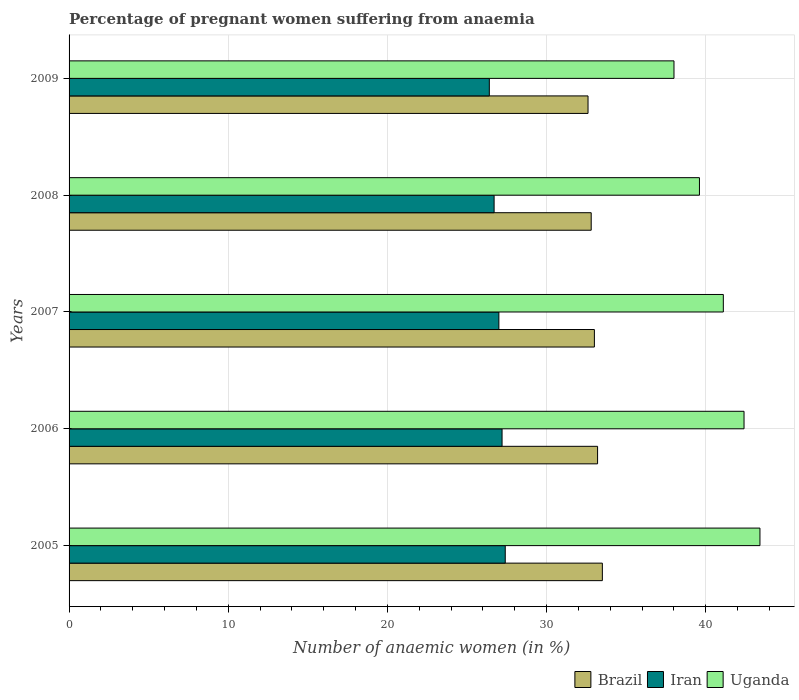How many groups of bars are there?
Offer a terse response. 5. Are the number of bars on each tick of the Y-axis equal?
Your response must be concise. Yes. How many bars are there on the 5th tick from the top?
Your answer should be compact. 3. How many bars are there on the 2nd tick from the bottom?
Provide a short and direct response. 3. What is the number of anaemic women in Brazil in 2006?
Provide a succinct answer. 33.2. Across all years, what is the maximum number of anaemic women in Iran?
Your answer should be very brief. 27.4. In which year was the number of anaemic women in Uganda maximum?
Make the answer very short. 2005. What is the total number of anaemic women in Brazil in the graph?
Your answer should be compact. 165.1. What is the difference between the number of anaemic women in Brazil in 2006 and that in 2007?
Your response must be concise. 0.2. What is the difference between the number of anaemic women in Brazil in 2005 and the number of anaemic women in Uganda in 2008?
Keep it short and to the point. -6.1. What is the average number of anaemic women in Iran per year?
Provide a succinct answer. 26.94. In the year 2007, what is the difference between the number of anaemic women in Brazil and number of anaemic women in Uganda?
Make the answer very short. -8.1. In how many years, is the number of anaemic women in Uganda greater than 34 %?
Offer a very short reply. 5. What is the ratio of the number of anaemic women in Uganda in 2005 to that in 2006?
Your answer should be very brief. 1.02. Is the number of anaemic women in Iran in 2006 less than that in 2007?
Your answer should be compact. No. Is the difference between the number of anaemic women in Brazil in 2007 and 2008 greater than the difference between the number of anaemic women in Uganda in 2007 and 2008?
Provide a succinct answer. No. What is the difference between the highest and the second highest number of anaemic women in Iran?
Offer a very short reply. 0.2. What is the difference between the highest and the lowest number of anaemic women in Uganda?
Make the answer very short. 5.4. In how many years, is the number of anaemic women in Brazil greater than the average number of anaemic women in Brazil taken over all years?
Provide a succinct answer. 2. Is the sum of the number of anaemic women in Brazil in 2005 and 2009 greater than the maximum number of anaemic women in Iran across all years?
Your answer should be very brief. Yes. What does the 1st bar from the top in 2006 represents?
Offer a terse response. Uganda. What does the 2nd bar from the bottom in 2007 represents?
Your response must be concise. Iran. Is it the case that in every year, the sum of the number of anaemic women in Iran and number of anaemic women in Uganda is greater than the number of anaemic women in Brazil?
Ensure brevity in your answer.  Yes. How many bars are there?
Ensure brevity in your answer.  15. Does the graph contain grids?
Keep it short and to the point. Yes. How many legend labels are there?
Ensure brevity in your answer.  3. How are the legend labels stacked?
Keep it short and to the point. Horizontal. What is the title of the graph?
Offer a very short reply. Percentage of pregnant women suffering from anaemia. Does "France" appear as one of the legend labels in the graph?
Your answer should be very brief. No. What is the label or title of the X-axis?
Provide a short and direct response. Number of anaemic women (in %). What is the label or title of the Y-axis?
Your response must be concise. Years. What is the Number of anaemic women (in %) in Brazil in 2005?
Give a very brief answer. 33.5. What is the Number of anaemic women (in %) in Iran in 2005?
Provide a short and direct response. 27.4. What is the Number of anaemic women (in %) in Uganda in 2005?
Your response must be concise. 43.4. What is the Number of anaemic women (in %) of Brazil in 2006?
Your answer should be compact. 33.2. What is the Number of anaemic women (in %) of Iran in 2006?
Your response must be concise. 27.2. What is the Number of anaemic women (in %) in Uganda in 2006?
Provide a short and direct response. 42.4. What is the Number of anaemic women (in %) in Iran in 2007?
Ensure brevity in your answer.  27. What is the Number of anaemic women (in %) in Uganda in 2007?
Keep it short and to the point. 41.1. What is the Number of anaemic women (in %) in Brazil in 2008?
Offer a very short reply. 32.8. What is the Number of anaemic women (in %) in Iran in 2008?
Your answer should be compact. 26.7. What is the Number of anaemic women (in %) in Uganda in 2008?
Provide a succinct answer. 39.6. What is the Number of anaemic women (in %) in Brazil in 2009?
Make the answer very short. 32.6. What is the Number of anaemic women (in %) of Iran in 2009?
Your response must be concise. 26.4. Across all years, what is the maximum Number of anaemic women (in %) in Brazil?
Keep it short and to the point. 33.5. Across all years, what is the maximum Number of anaemic women (in %) in Iran?
Ensure brevity in your answer.  27.4. Across all years, what is the maximum Number of anaemic women (in %) in Uganda?
Give a very brief answer. 43.4. Across all years, what is the minimum Number of anaemic women (in %) of Brazil?
Make the answer very short. 32.6. Across all years, what is the minimum Number of anaemic women (in %) in Iran?
Your answer should be very brief. 26.4. Across all years, what is the minimum Number of anaemic women (in %) in Uganda?
Provide a short and direct response. 38. What is the total Number of anaemic women (in %) in Brazil in the graph?
Your answer should be compact. 165.1. What is the total Number of anaemic women (in %) in Iran in the graph?
Offer a terse response. 134.7. What is the total Number of anaemic women (in %) of Uganda in the graph?
Offer a very short reply. 204.5. What is the difference between the Number of anaemic women (in %) in Brazil in 2005 and that in 2006?
Make the answer very short. 0.3. What is the difference between the Number of anaemic women (in %) of Iran in 2005 and that in 2006?
Offer a terse response. 0.2. What is the difference between the Number of anaemic women (in %) of Uganda in 2005 and that in 2006?
Make the answer very short. 1. What is the difference between the Number of anaemic women (in %) in Brazil in 2005 and that in 2007?
Provide a short and direct response. 0.5. What is the difference between the Number of anaemic women (in %) of Uganda in 2005 and that in 2007?
Your response must be concise. 2.3. What is the difference between the Number of anaemic women (in %) in Iran in 2005 and that in 2009?
Give a very brief answer. 1. What is the difference between the Number of anaemic women (in %) in Uganda in 2005 and that in 2009?
Offer a terse response. 5.4. What is the difference between the Number of anaemic women (in %) in Iran in 2006 and that in 2007?
Give a very brief answer. 0.2. What is the difference between the Number of anaemic women (in %) in Brazil in 2006 and that in 2008?
Your answer should be very brief. 0.4. What is the difference between the Number of anaemic women (in %) in Iran in 2006 and that in 2008?
Offer a very short reply. 0.5. What is the difference between the Number of anaemic women (in %) in Iran in 2007 and that in 2008?
Ensure brevity in your answer.  0.3. What is the difference between the Number of anaemic women (in %) in Uganda in 2007 and that in 2008?
Provide a succinct answer. 1.5. What is the difference between the Number of anaemic women (in %) of Brazil in 2007 and that in 2009?
Provide a short and direct response. 0.4. What is the difference between the Number of anaemic women (in %) in Uganda in 2007 and that in 2009?
Provide a short and direct response. 3.1. What is the difference between the Number of anaemic women (in %) in Iran in 2008 and that in 2009?
Make the answer very short. 0.3. What is the difference between the Number of anaemic women (in %) in Brazil in 2005 and the Number of anaemic women (in %) in Uganda in 2006?
Keep it short and to the point. -8.9. What is the difference between the Number of anaemic women (in %) of Brazil in 2005 and the Number of anaemic women (in %) of Iran in 2007?
Your response must be concise. 6.5. What is the difference between the Number of anaemic women (in %) in Brazil in 2005 and the Number of anaemic women (in %) in Uganda in 2007?
Provide a short and direct response. -7.6. What is the difference between the Number of anaemic women (in %) in Iran in 2005 and the Number of anaemic women (in %) in Uganda in 2007?
Give a very brief answer. -13.7. What is the difference between the Number of anaemic women (in %) in Brazil in 2005 and the Number of anaemic women (in %) in Uganda in 2008?
Provide a short and direct response. -6.1. What is the difference between the Number of anaemic women (in %) of Brazil in 2005 and the Number of anaemic women (in %) of Uganda in 2009?
Make the answer very short. -4.5. What is the difference between the Number of anaemic women (in %) in Iran in 2005 and the Number of anaemic women (in %) in Uganda in 2009?
Give a very brief answer. -10.6. What is the difference between the Number of anaemic women (in %) of Brazil in 2006 and the Number of anaemic women (in %) of Iran in 2007?
Your answer should be very brief. 6.2. What is the difference between the Number of anaemic women (in %) of Brazil in 2006 and the Number of anaemic women (in %) of Uganda in 2007?
Give a very brief answer. -7.9. What is the difference between the Number of anaemic women (in %) of Iran in 2006 and the Number of anaemic women (in %) of Uganda in 2008?
Provide a short and direct response. -12.4. What is the difference between the Number of anaemic women (in %) of Brazil in 2006 and the Number of anaemic women (in %) of Uganda in 2009?
Your answer should be very brief. -4.8. What is the difference between the Number of anaemic women (in %) in Iran in 2006 and the Number of anaemic women (in %) in Uganda in 2009?
Make the answer very short. -10.8. What is the difference between the Number of anaemic women (in %) of Brazil in 2007 and the Number of anaemic women (in %) of Uganda in 2008?
Keep it short and to the point. -6.6. What is the difference between the Number of anaemic women (in %) of Iran in 2007 and the Number of anaemic women (in %) of Uganda in 2008?
Give a very brief answer. -12.6. What is the difference between the Number of anaemic women (in %) in Brazil in 2007 and the Number of anaemic women (in %) in Uganda in 2009?
Your answer should be very brief. -5. What is the difference between the Number of anaemic women (in %) of Iran in 2007 and the Number of anaemic women (in %) of Uganda in 2009?
Offer a terse response. -11. What is the difference between the Number of anaemic women (in %) in Brazil in 2008 and the Number of anaemic women (in %) in Iran in 2009?
Provide a succinct answer. 6.4. What is the average Number of anaemic women (in %) of Brazil per year?
Your response must be concise. 33.02. What is the average Number of anaemic women (in %) in Iran per year?
Your answer should be compact. 26.94. What is the average Number of anaemic women (in %) of Uganda per year?
Keep it short and to the point. 40.9. In the year 2005, what is the difference between the Number of anaemic women (in %) in Brazil and Number of anaemic women (in %) in Iran?
Make the answer very short. 6.1. In the year 2006, what is the difference between the Number of anaemic women (in %) of Brazil and Number of anaemic women (in %) of Uganda?
Ensure brevity in your answer.  -9.2. In the year 2006, what is the difference between the Number of anaemic women (in %) of Iran and Number of anaemic women (in %) of Uganda?
Make the answer very short. -15.2. In the year 2007, what is the difference between the Number of anaemic women (in %) in Brazil and Number of anaemic women (in %) in Uganda?
Keep it short and to the point. -8.1. In the year 2007, what is the difference between the Number of anaemic women (in %) in Iran and Number of anaemic women (in %) in Uganda?
Give a very brief answer. -14.1. In the year 2008, what is the difference between the Number of anaemic women (in %) in Iran and Number of anaemic women (in %) in Uganda?
Ensure brevity in your answer.  -12.9. In the year 2009, what is the difference between the Number of anaemic women (in %) in Brazil and Number of anaemic women (in %) in Uganda?
Provide a succinct answer. -5.4. What is the ratio of the Number of anaemic women (in %) in Iran in 2005 to that in 2006?
Make the answer very short. 1.01. What is the ratio of the Number of anaemic women (in %) in Uganda in 2005 to that in 2006?
Offer a terse response. 1.02. What is the ratio of the Number of anaemic women (in %) in Brazil in 2005 to that in 2007?
Your response must be concise. 1.02. What is the ratio of the Number of anaemic women (in %) in Iran in 2005 to that in 2007?
Your answer should be compact. 1.01. What is the ratio of the Number of anaemic women (in %) of Uganda in 2005 to that in 2007?
Your answer should be very brief. 1.06. What is the ratio of the Number of anaemic women (in %) in Brazil in 2005 to that in 2008?
Provide a short and direct response. 1.02. What is the ratio of the Number of anaemic women (in %) of Iran in 2005 to that in 2008?
Make the answer very short. 1.03. What is the ratio of the Number of anaemic women (in %) of Uganda in 2005 to that in 2008?
Your answer should be very brief. 1.1. What is the ratio of the Number of anaemic women (in %) in Brazil in 2005 to that in 2009?
Provide a short and direct response. 1.03. What is the ratio of the Number of anaemic women (in %) of Iran in 2005 to that in 2009?
Ensure brevity in your answer.  1.04. What is the ratio of the Number of anaemic women (in %) in Uganda in 2005 to that in 2009?
Ensure brevity in your answer.  1.14. What is the ratio of the Number of anaemic women (in %) of Iran in 2006 to that in 2007?
Offer a terse response. 1.01. What is the ratio of the Number of anaemic women (in %) in Uganda in 2006 to that in 2007?
Make the answer very short. 1.03. What is the ratio of the Number of anaemic women (in %) in Brazil in 2006 to that in 2008?
Provide a short and direct response. 1.01. What is the ratio of the Number of anaemic women (in %) in Iran in 2006 to that in 2008?
Ensure brevity in your answer.  1.02. What is the ratio of the Number of anaemic women (in %) in Uganda in 2006 to that in 2008?
Offer a terse response. 1.07. What is the ratio of the Number of anaemic women (in %) of Brazil in 2006 to that in 2009?
Give a very brief answer. 1.02. What is the ratio of the Number of anaemic women (in %) of Iran in 2006 to that in 2009?
Ensure brevity in your answer.  1.03. What is the ratio of the Number of anaemic women (in %) of Uganda in 2006 to that in 2009?
Keep it short and to the point. 1.12. What is the ratio of the Number of anaemic women (in %) of Brazil in 2007 to that in 2008?
Your answer should be very brief. 1.01. What is the ratio of the Number of anaemic women (in %) of Iran in 2007 to that in 2008?
Keep it short and to the point. 1.01. What is the ratio of the Number of anaemic women (in %) in Uganda in 2007 to that in 2008?
Offer a terse response. 1.04. What is the ratio of the Number of anaemic women (in %) in Brazil in 2007 to that in 2009?
Ensure brevity in your answer.  1.01. What is the ratio of the Number of anaemic women (in %) in Iran in 2007 to that in 2009?
Your answer should be compact. 1.02. What is the ratio of the Number of anaemic women (in %) in Uganda in 2007 to that in 2009?
Offer a very short reply. 1.08. What is the ratio of the Number of anaemic women (in %) in Iran in 2008 to that in 2009?
Offer a very short reply. 1.01. What is the ratio of the Number of anaemic women (in %) in Uganda in 2008 to that in 2009?
Provide a short and direct response. 1.04. What is the difference between the highest and the second highest Number of anaemic women (in %) of Brazil?
Give a very brief answer. 0.3. What is the difference between the highest and the second highest Number of anaemic women (in %) in Uganda?
Give a very brief answer. 1. What is the difference between the highest and the lowest Number of anaemic women (in %) in Iran?
Keep it short and to the point. 1. 